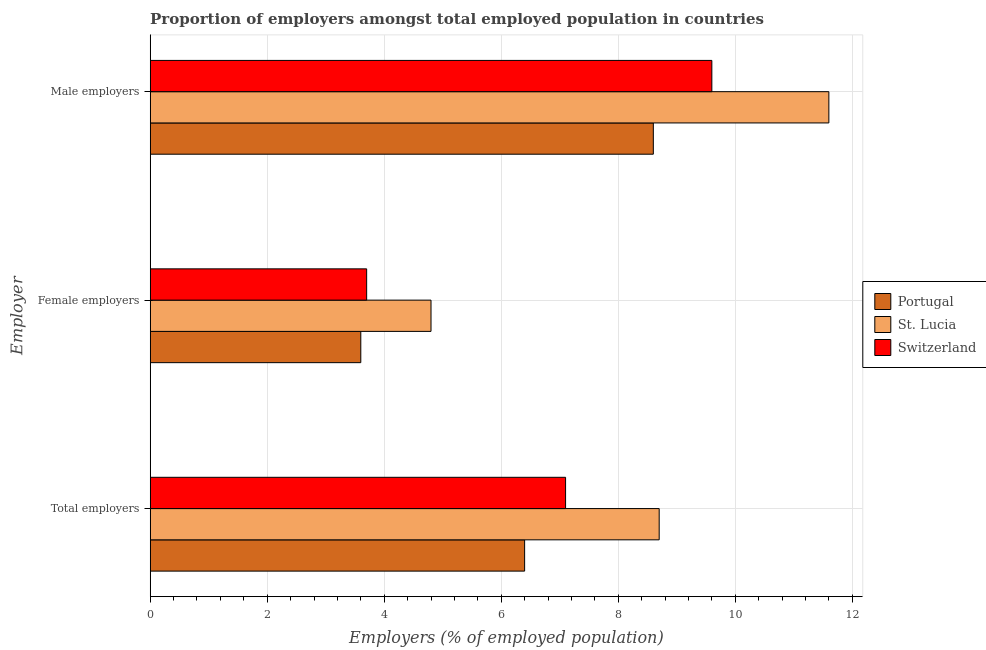How many different coloured bars are there?
Keep it short and to the point. 3. How many bars are there on the 1st tick from the top?
Provide a succinct answer. 3. How many bars are there on the 3rd tick from the bottom?
Keep it short and to the point. 3. What is the label of the 3rd group of bars from the top?
Provide a succinct answer. Total employers. What is the percentage of male employers in Portugal?
Provide a succinct answer. 8.6. Across all countries, what is the maximum percentage of total employers?
Your answer should be compact. 8.7. Across all countries, what is the minimum percentage of total employers?
Provide a succinct answer. 6.4. In which country was the percentage of female employers maximum?
Give a very brief answer. St. Lucia. In which country was the percentage of female employers minimum?
Provide a short and direct response. Portugal. What is the total percentage of total employers in the graph?
Give a very brief answer. 22.2. What is the difference between the percentage of female employers in Switzerland and that in St. Lucia?
Make the answer very short. -1.1. What is the difference between the percentage of male employers in Switzerland and the percentage of female employers in St. Lucia?
Your answer should be very brief. 4.8. What is the average percentage of male employers per country?
Offer a very short reply. 9.93. What is the difference between the percentage of male employers and percentage of total employers in Switzerland?
Provide a succinct answer. 2.5. What is the ratio of the percentage of male employers in Portugal to that in Switzerland?
Provide a succinct answer. 0.9. What is the difference between the highest and the second highest percentage of female employers?
Provide a short and direct response. 1.1. What is the difference between the highest and the lowest percentage of total employers?
Offer a very short reply. 2.3. In how many countries, is the percentage of female employers greater than the average percentage of female employers taken over all countries?
Ensure brevity in your answer.  1. Is the sum of the percentage of male employers in St. Lucia and Portugal greater than the maximum percentage of female employers across all countries?
Provide a succinct answer. Yes. What does the 2nd bar from the bottom in Male employers represents?
Make the answer very short. St. Lucia. Are all the bars in the graph horizontal?
Offer a terse response. Yes. How many countries are there in the graph?
Provide a short and direct response. 3. Does the graph contain any zero values?
Provide a succinct answer. No. Where does the legend appear in the graph?
Offer a very short reply. Center right. How many legend labels are there?
Your response must be concise. 3. What is the title of the graph?
Your answer should be compact. Proportion of employers amongst total employed population in countries. What is the label or title of the X-axis?
Your answer should be compact. Employers (% of employed population). What is the label or title of the Y-axis?
Offer a very short reply. Employer. What is the Employers (% of employed population) in Portugal in Total employers?
Offer a very short reply. 6.4. What is the Employers (% of employed population) in St. Lucia in Total employers?
Your response must be concise. 8.7. What is the Employers (% of employed population) in Switzerland in Total employers?
Make the answer very short. 7.1. What is the Employers (% of employed population) in Portugal in Female employers?
Offer a very short reply. 3.6. What is the Employers (% of employed population) in St. Lucia in Female employers?
Give a very brief answer. 4.8. What is the Employers (% of employed population) of Switzerland in Female employers?
Make the answer very short. 3.7. What is the Employers (% of employed population) in Portugal in Male employers?
Offer a terse response. 8.6. What is the Employers (% of employed population) in St. Lucia in Male employers?
Provide a short and direct response. 11.6. What is the Employers (% of employed population) of Switzerland in Male employers?
Offer a terse response. 9.6. Across all Employer, what is the maximum Employers (% of employed population) of Portugal?
Your response must be concise. 8.6. Across all Employer, what is the maximum Employers (% of employed population) in St. Lucia?
Give a very brief answer. 11.6. Across all Employer, what is the maximum Employers (% of employed population) of Switzerland?
Ensure brevity in your answer.  9.6. Across all Employer, what is the minimum Employers (% of employed population) of Portugal?
Ensure brevity in your answer.  3.6. Across all Employer, what is the minimum Employers (% of employed population) of St. Lucia?
Provide a short and direct response. 4.8. Across all Employer, what is the minimum Employers (% of employed population) of Switzerland?
Make the answer very short. 3.7. What is the total Employers (% of employed population) of St. Lucia in the graph?
Ensure brevity in your answer.  25.1. What is the total Employers (% of employed population) of Switzerland in the graph?
Your answer should be very brief. 20.4. What is the difference between the Employers (% of employed population) in St. Lucia in Total employers and that in Female employers?
Provide a succinct answer. 3.9. What is the difference between the Employers (% of employed population) of St. Lucia in Total employers and that in Male employers?
Make the answer very short. -2.9. What is the difference between the Employers (% of employed population) of Switzerland in Total employers and that in Male employers?
Provide a succinct answer. -2.5. What is the difference between the Employers (% of employed population) in St. Lucia in Female employers and that in Male employers?
Provide a short and direct response. -6.8. What is the difference between the Employers (% of employed population) of Portugal in Total employers and the Employers (% of employed population) of St. Lucia in Female employers?
Keep it short and to the point. 1.6. What is the difference between the Employers (% of employed population) in St. Lucia in Total employers and the Employers (% of employed population) in Switzerland in Female employers?
Offer a very short reply. 5. What is the difference between the Employers (% of employed population) of Portugal in Female employers and the Employers (% of employed population) of Switzerland in Male employers?
Your answer should be compact. -6. What is the average Employers (% of employed population) in St. Lucia per Employer?
Your response must be concise. 8.37. What is the average Employers (% of employed population) of Switzerland per Employer?
Your answer should be compact. 6.8. What is the difference between the Employers (% of employed population) in Portugal and Employers (% of employed population) in St. Lucia in Total employers?
Ensure brevity in your answer.  -2.3. What is the difference between the Employers (% of employed population) in Portugal and Employers (% of employed population) in Switzerland in Total employers?
Your answer should be compact. -0.7. What is the difference between the Employers (% of employed population) in Portugal and Employers (% of employed population) in St. Lucia in Female employers?
Your answer should be compact. -1.2. What is the difference between the Employers (% of employed population) of St. Lucia and Employers (% of employed population) of Switzerland in Female employers?
Offer a terse response. 1.1. What is the difference between the Employers (% of employed population) in Portugal and Employers (% of employed population) in St. Lucia in Male employers?
Make the answer very short. -3. What is the difference between the Employers (% of employed population) of Portugal and Employers (% of employed population) of Switzerland in Male employers?
Your answer should be very brief. -1. What is the difference between the Employers (% of employed population) in St. Lucia and Employers (% of employed population) in Switzerland in Male employers?
Make the answer very short. 2. What is the ratio of the Employers (% of employed population) of Portugal in Total employers to that in Female employers?
Make the answer very short. 1.78. What is the ratio of the Employers (% of employed population) in St. Lucia in Total employers to that in Female employers?
Provide a short and direct response. 1.81. What is the ratio of the Employers (% of employed population) in Switzerland in Total employers to that in Female employers?
Your answer should be very brief. 1.92. What is the ratio of the Employers (% of employed population) of Portugal in Total employers to that in Male employers?
Give a very brief answer. 0.74. What is the ratio of the Employers (% of employed population) of St. Lucia in Total employers to that in Male employers?
Provide a short and direct response. 0.75. What is the ratio of the Employers (% of employed population) in Switzerland in Total employers to that in Male employers?
Keep it short and to the point. 0.74. What is the ratio of the Employers (% of employed population) of Portugal in Female employers to that in Male employers?
Your answer should be compact. 0.42. What is the ratio of the Employers (% of employed population) in St. Lucia in Female employers to that in Male employers?
Your answer should be very brief. 0.41. What is the ratio of the Employers (% of employed population) of Switzerland in Female employers to that in Male employers?
Keep it short and to the point. 0.39. What is the difference between the highest and the second highest Employers (% of employed population) of Portugal?
Your answer should be compact. 2.2. What is the difference between the highest and the second highest Employers (% of employed population) of St. Lucia?
Keep it short and to the point. 2.9. What is the difference between the highest and the second highest Employers (% of employed population) of Switzerland?
Provide a short and direct response. 2.5. What is the difference between the highest and the lowest Employers (% of employed population) of Portugal?
Your answer should be very brief. 5. 